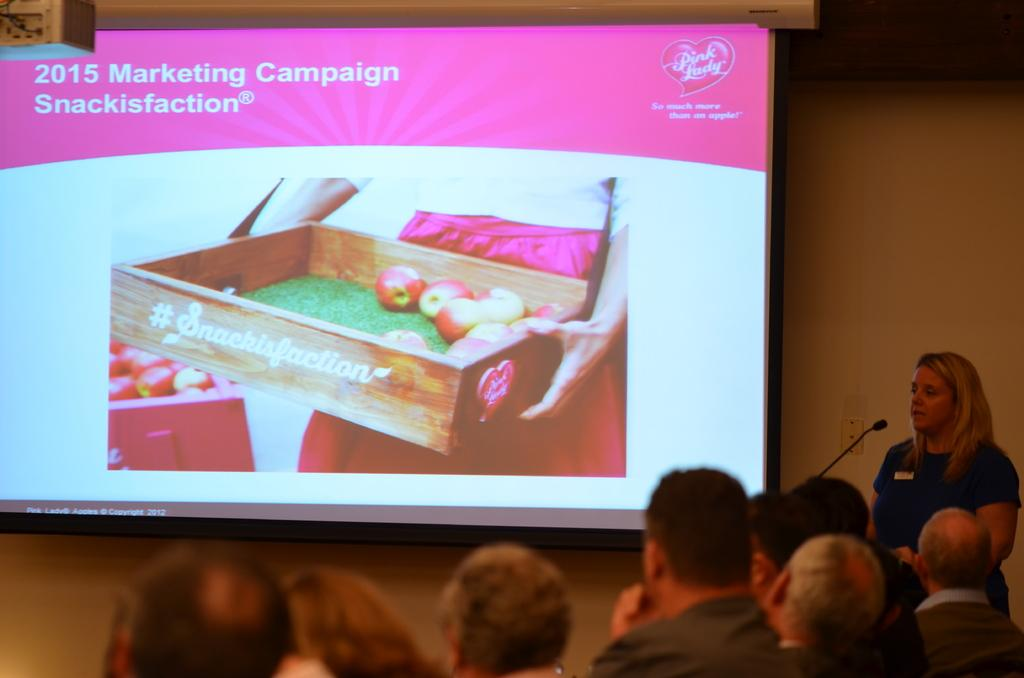What are the people in the image doing? The people in the image are sitting at the bottom. Can you describe the woman's position in the image? The woman is standing on the right side of the image. What is the main object in the middle of the image? There is a screen in the middle of the image. What type of yarn is being used to create the downtown scene on the screen? There is no yarn or downtown scene mentioned in the image. How many jelly containers are visible on the screen? There is no mention of jelly or containers in the image. 